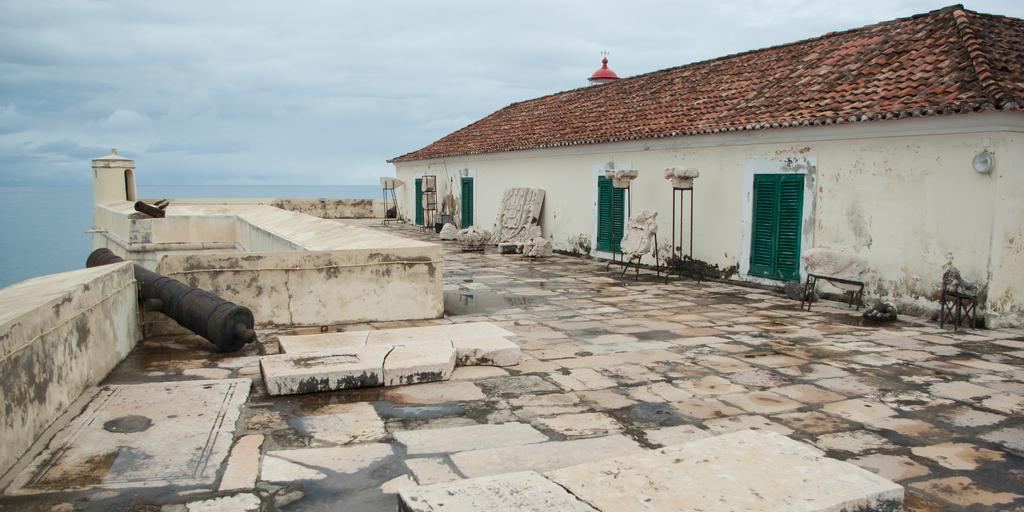What type of surface is visible in the image? The surface in the image has tiles. What is the color of the doors on the house in the image? The house in the image has green doors. What can be seen near the house in the image? There are objects near the house in the image. What is visible in the background of the image? The sky is visible in the background of the image. What can be observed in the sky in the image? Clouds are present in the sky in the image. Can you see a kitty playing with a quill in the image? There is no kitty or quill present in the image. Is the house in the image located in space? The image does not suggest that the house is located in space; it appears to be on a tiled surface with a visible sky in the background. 